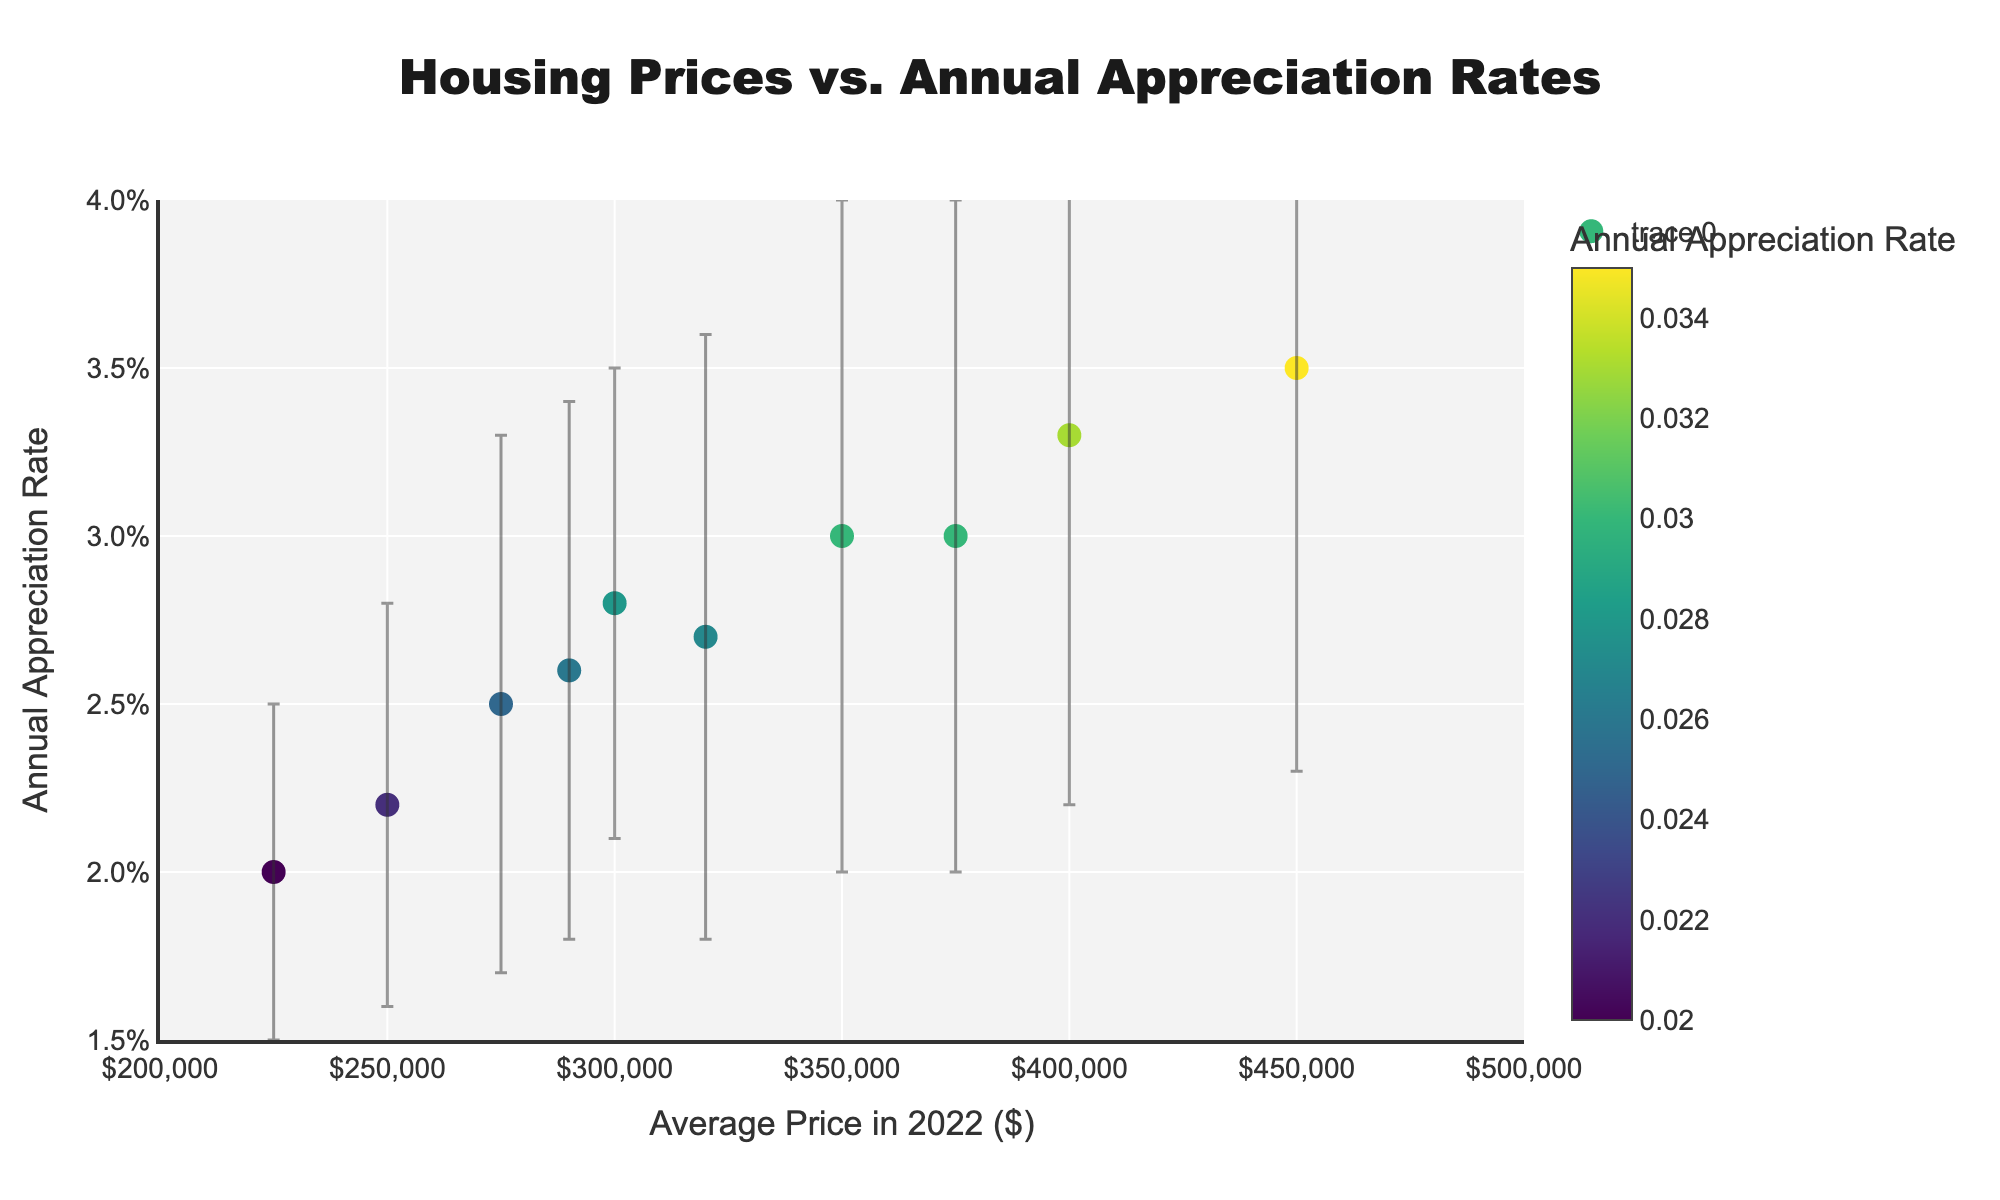What's the title of the figure? The title is usually displayed prominently at the top of the figure. In this case, it's "Housing Prices vs. Annual Appreciation Rates".
Answer: Housing Prices vs. Annual Appreciation Rates What is the range of the x-axis representing the average prices in 2022? The x-axis starts from $200,000 and goes up to $500,000, indicating the range of average prices in 2022.
Answer: $200,000 to $500,000 Which neighborhood has the highest average price in 2022? The highest average price in 2022 can be determined by looking at the far right end of the x-axis. Lakeside, with an average price of $450,000, is the highest.
Answer: Lakeside Which neighborhood has the lowest annual appreciation rate? The lowest annual appreciation rate can be identified by looking at the bottom of the y-axis. Brookside, with an annual appreciation rate of 0.02, is the lowest.
Answer: Brookside Which two neighborhoods have the same average price but different annual appreciation rates? By looking at points that align vertically but have different y-values, we see that Greenwood and West Hill both have an average price of $375,000 but different annual appreciation rates (0.03 and 0.03 respectively).
Answer: Greenwood and West Hill What is the range of uncertainty in the annual appreciation rate for Hillcrest? Uncertainty is represented by error bars. For Hillcrest, the error bars extend from 0.021 to 0.035, meaning the uncertainty range is 0.014 (0.035 - 0.021).
Answer: 0.014 Which neighborhood has the largest uncertainty in the annual appreciation rate? The largest uncertainty can be found by comparing the lengths of the error bars. Lakeside, with an uncertainty of 0.012, has the longest error bars.
Answer: Lakeside Is there a correlation between average price and annual appreciation rate? From the scatter plot, if the points generally move upward as we move right, this indicates a positive correlation. The plot shows a loose upward trend, implying a positive correlation between average price and annual appreciation rate.
Answer: Yes, there is a positive correlation What is the average annual appreciation rate across all neighborhoods? To find the average, sum up all the annual appreciation rates and divide by the number of neighborhoods: (0.03 + 0.025 + 0.035 + 0.028 + 0.02 + 0.033 + 0.027 + 0.022 + 0.03 + 0.026) / 10 = 0.0276.
Answer: 0.0276 